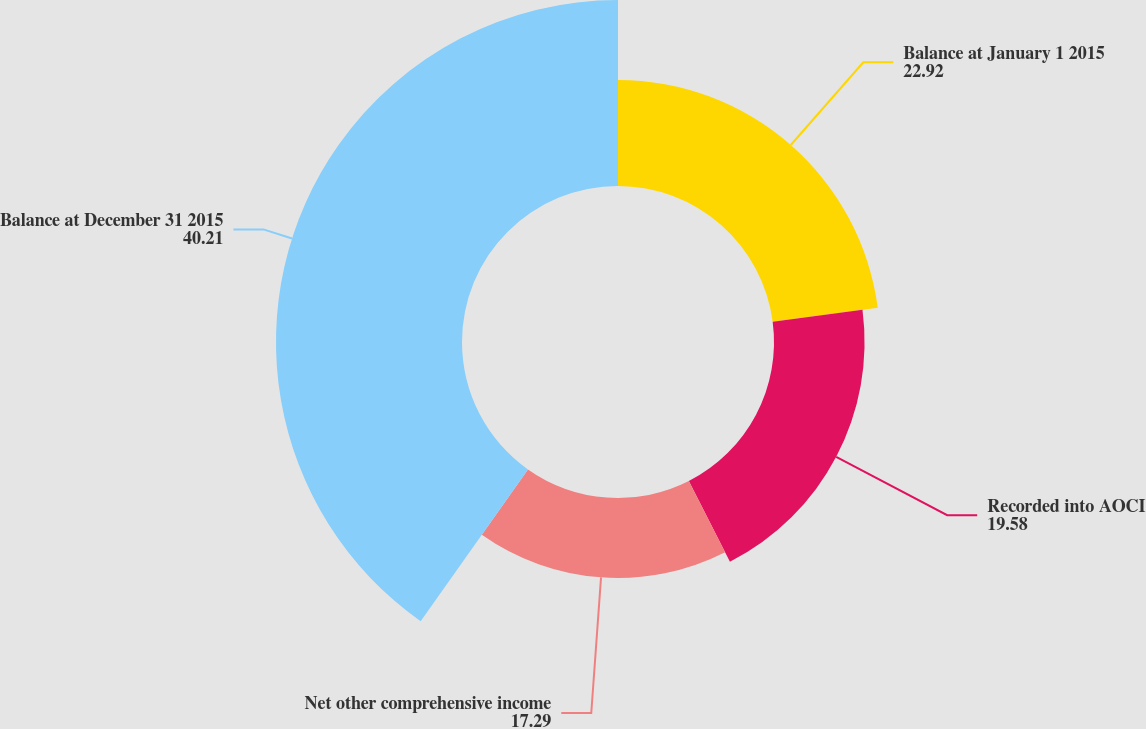<chart> <loc_0><loc_0><loc_500><loc_500><pie_chart><fcel>Balance at January 1 2015<fcel>Recorded into AOCI<fcel>Net other comprehensive income<fcel>Balance at December 31 2015<nl><fcel>22.92%<fcel>19.58%<fcel>17.29%<fcel>40.21%<nl></chart> 